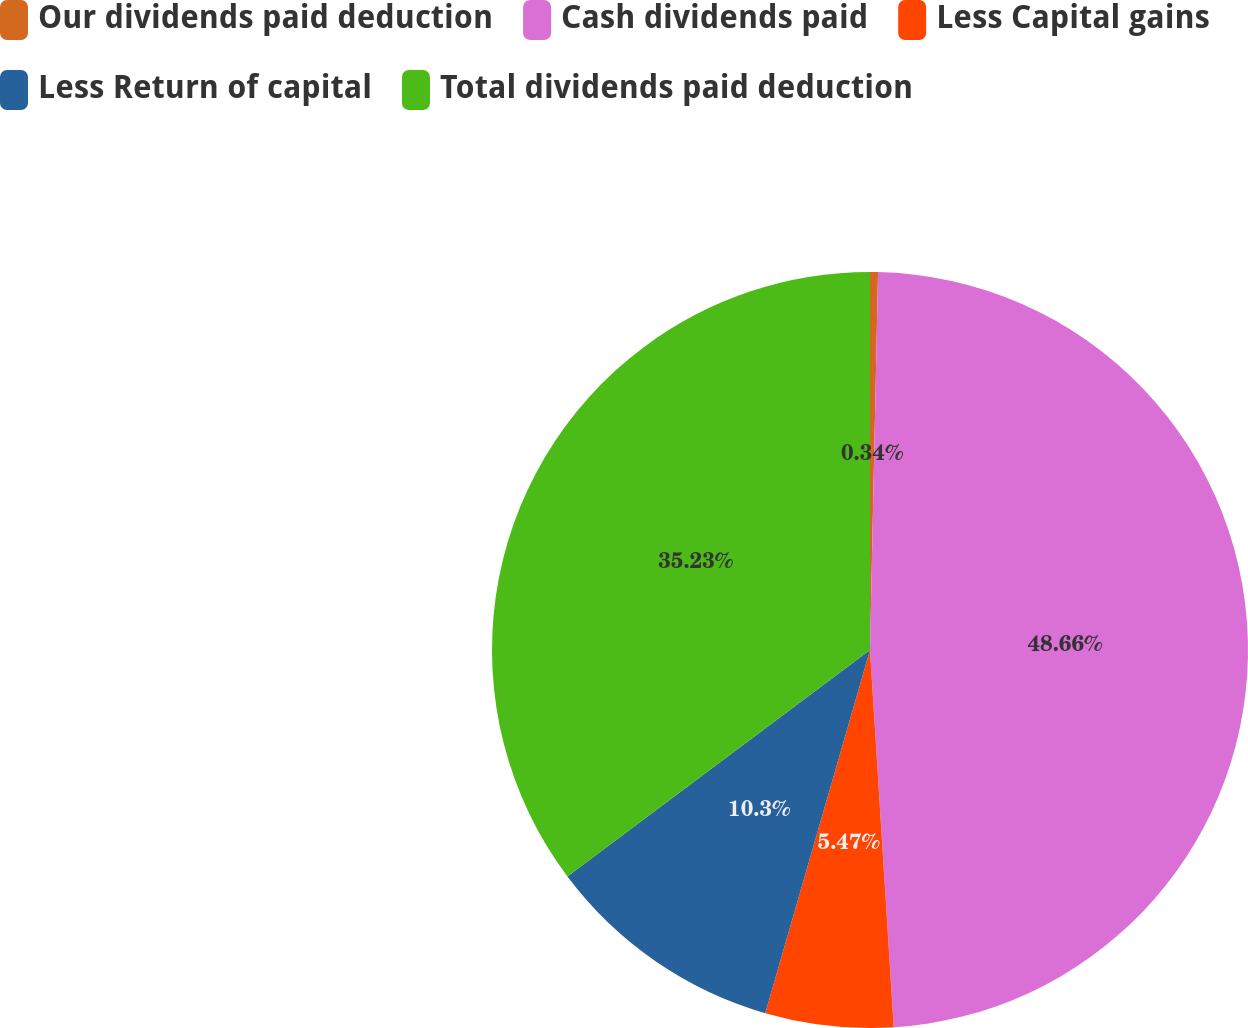<chart> <loc_0><loc_0><loc_500><loc_500><pie_chart><fcel>Our dividends paid deduction<fcel>Cash dividends paid<fcel>Less Capital gains<fcel>Less Return of capital<fcel>Total dividends paid deduction<nl><fcel>0.34%<fcel>48.66%<fcel>5.47%<fcel>10.3%<fcel>35.23%<nl></chart> 